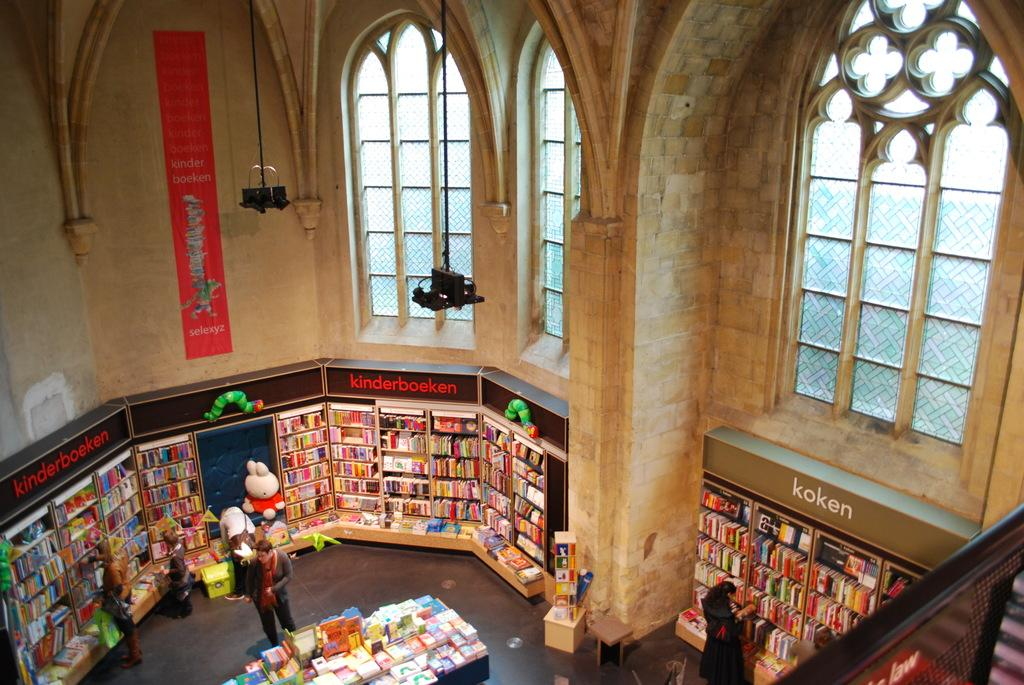<image>
Present a compact description of the photo's key features. the inside of a shop that has a top sign above the shelves that says 'kinderboeken' 